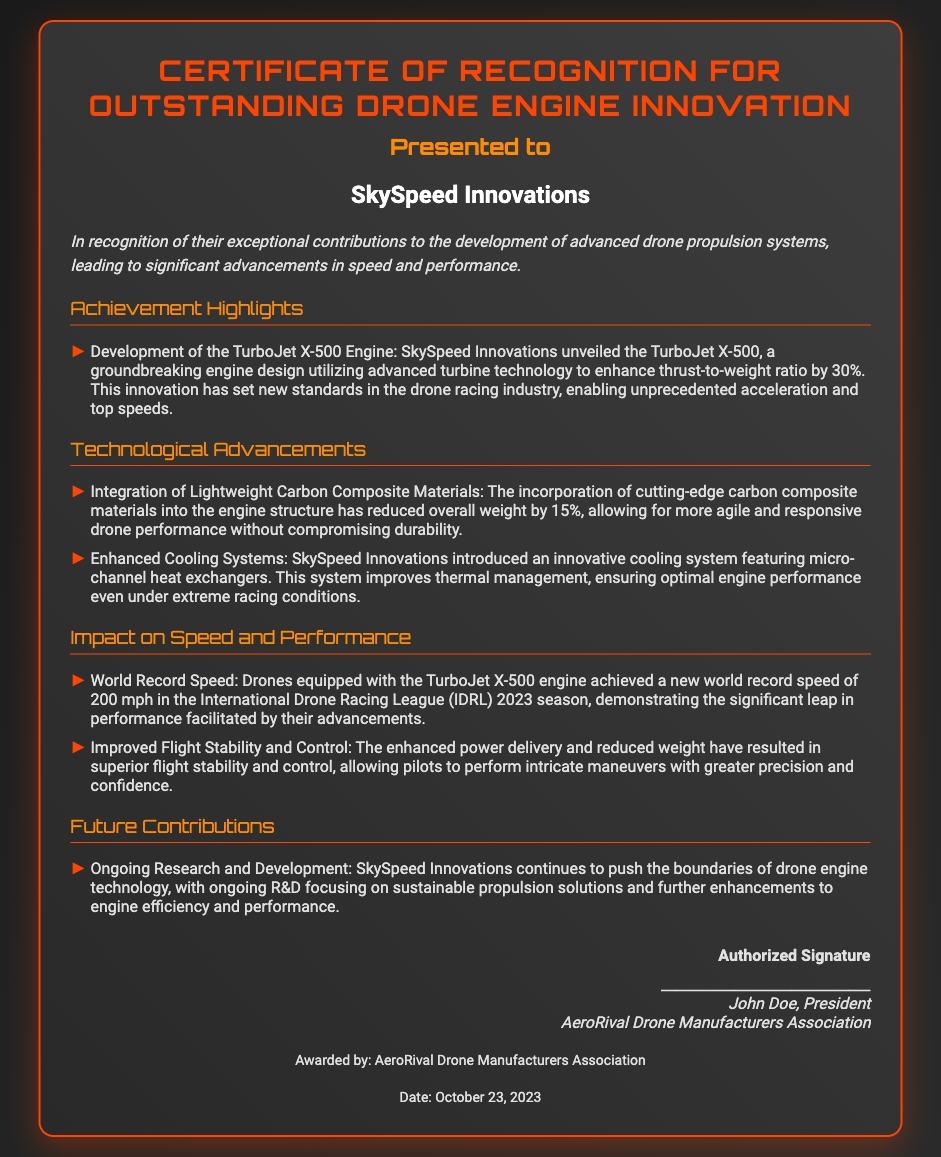What is the title of the certificate? The title of the certificate is stated at the top of the document.
Answer: Certificate of Recognition for Outstanding Drone Engine Innovation Who is the recipient of the award? The recipient's name is prominently displayed in the certificate.
Answer: SkySpeed Innovations What is the date awarded? The date the certificate was awarded is mentioned at the bottom of the document.
Answer: October 23, 2023 What engine did SkySpeed Innovations develop? The specific engine mentioned in the highlights section is made clear.
Answer: TurboJet X-500 What was the percentage improvement in thrust-to-weight ratio? The document specifies the enhancement made to the thrust-to-weight ratio.
Answer: 30% What was the world record speed achieved? The document details the new record speed achieved by drones with the engine.
Answer: 200 mph What materials were integrated to reduce weight? The type of materials used for the engine structure is highlighted in the technological advancements section.
Answer: Carbon Composite Materials Who signed the certificate? The authorized person's name is provided in the signature section.
Answer: John Doe What does SkySpeed Innovations continue to focus on? The future contributions section outlines ongoing work by the company.
Answer: Sustainable propulsion solutions 